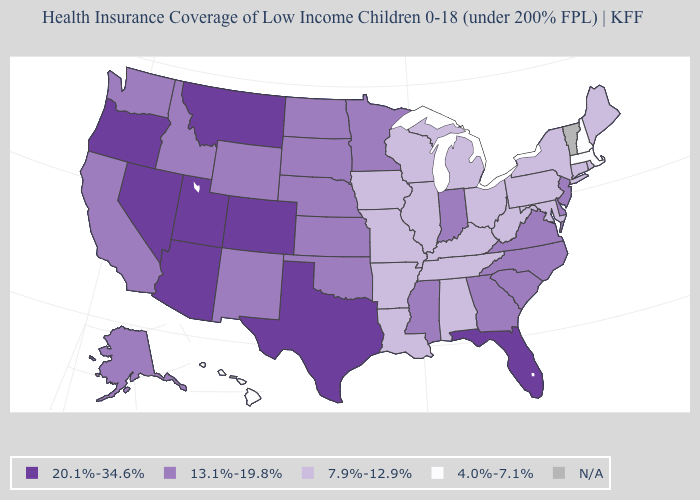Name the states that have a value in the range 4.0%-7.1%?
Keep it brief. Hawaii, Massachusetts, New Hampshire. Name the states that have a value in the range N/A?
Be succinct. Vermont. Does the map have missing data?
Short answer required. Yes. How many symbols are there in the legend?
Be succinct. 5. Name the states that have a value in the range 20.1%-34.6%?
Be succinct. Arizona, Colorado, Florida, Montana, Nevada, Oregon, Texas, Utah. What is the value of Colorado?
Short answer required. 20.1%-34.6%. What is the value of Maryland?
Keep it brief. 7.9%-12.9%. What is the lowest value in the USA?
Give a very brief answer. 4.0%-7.1%. What is the highest value in the MidWest ?
Keep it brief. 13.1%-19.8%. Among the states that border Massachusetts , which have the highest value?
Give a very brief answer. Connecticut, New York, Rhode Island. What is the value of Minnesota?
Be succinct. 13.1%-19.8%. Does the first symbol in the legend represent the smallest category?
Keep it brief. No. Which states have the lowest value in the USA?
Concise answer only. Hawaii, Massachusetts, New Hampshire. 